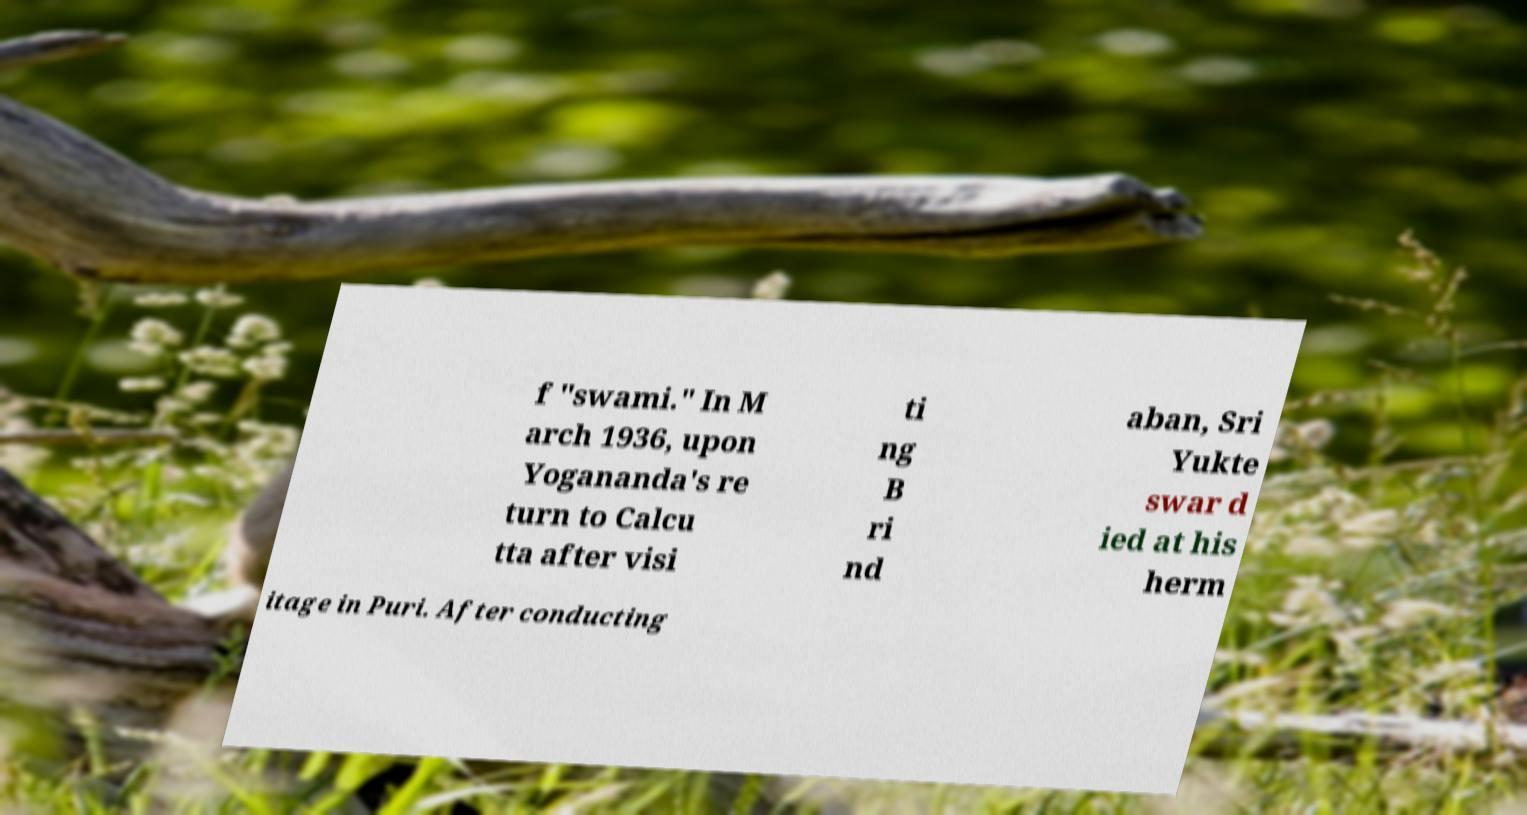There's text embedded in this image that I need extracted. Can you transcribe it verbatim? f "swami." In M arch 1936, upon Yogananda's re turn to Calcu tta after visi ti ng B ri nd aban, Sri Yukte swar d ied at his herm itage in Puri. After conducting 